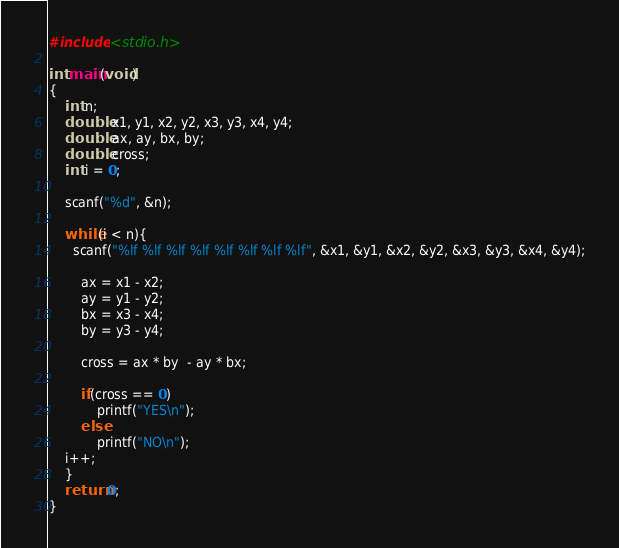<code> <loc_0><loc_0><loc_500><loc_500><_C_>#include <stdio.h>

int main(void)
{
    int n;
    double x1, y1, x2, y2, x3, y3, x4, y4;
    double ax, ay, bx, by;
    double cross;
    int i = 0;

    scanf("%d", &n);

    while(i < n){
      scanf("%lf %lf %lf %lf %lf %lf %lf %lf", &x1, &y1, &x2, &y2, &x3, &y3, &x4, &y4);

        ax = x1 - x2;
        ay = y1 - y2;
        bx = x3 - x4;
        by = y3 - y4;

        cross = ax * by  - ay * bx;
  
        if(cross == 0)
            printf("YES\n");
        else
            printf("NO\n");
	i++;
    }
    return 0;
}</code> 